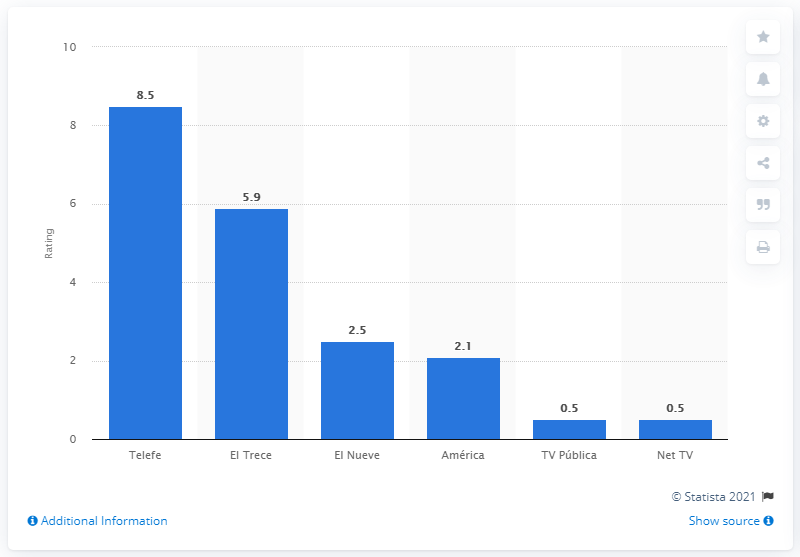Draw attention to some important aspects in this diagram. In June 2020, Telefe was the leading free television channel in Argentina. In June 2020, Telefe's rating was 8.5. 